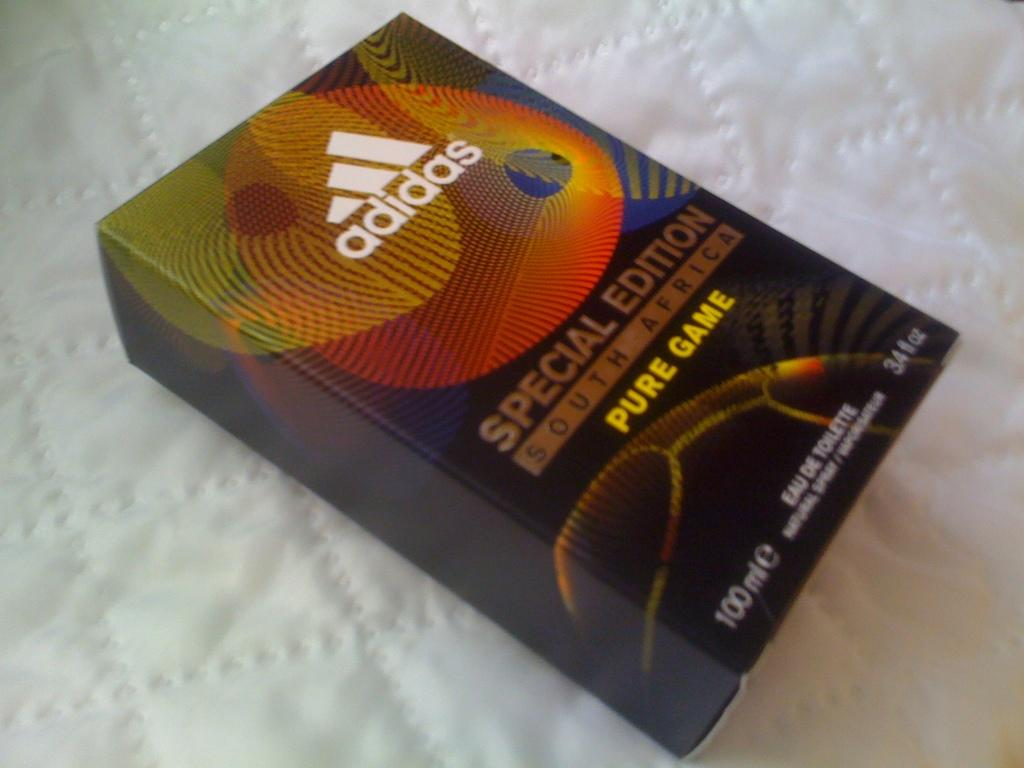<image>
Offer a succinct explanation of the picture presented. Special edition book regarding South Africa from Adidas. 